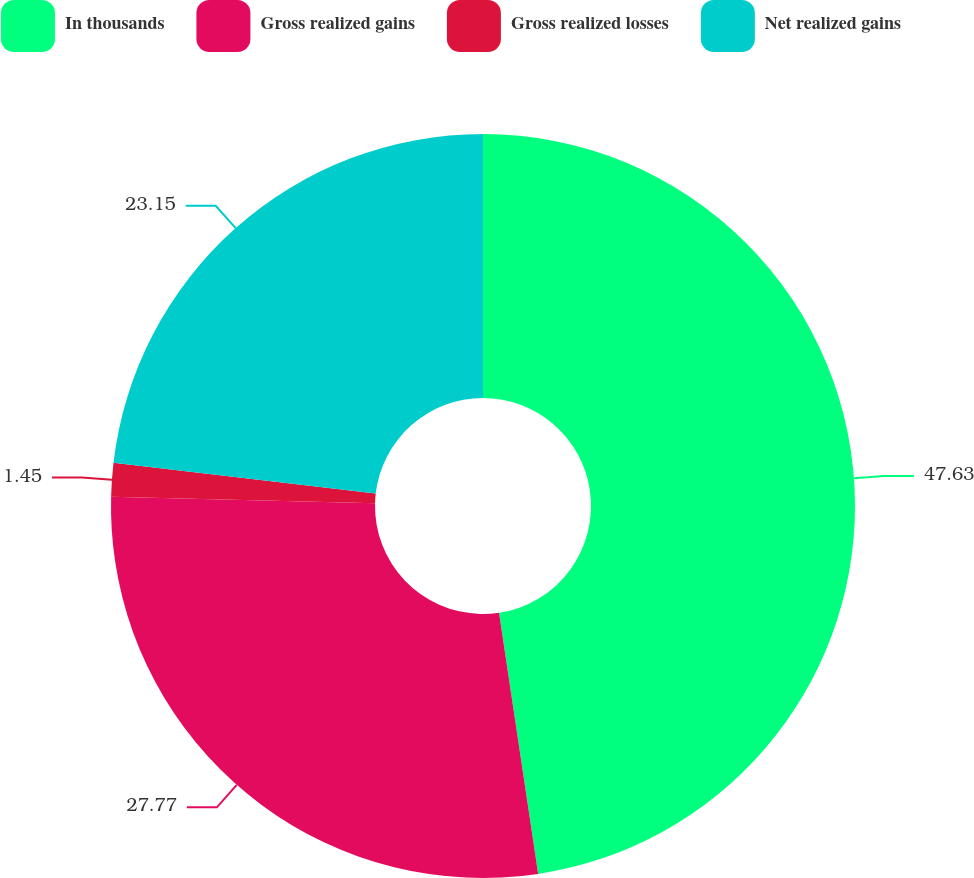<chart> <loc_0><loc_0><loc_500><loc_500><pie_chart><fcel>In thousands<fcel>Gross realized gains<fcel>Gross realized losses<fcel>Net realized gains<nl><fcel>47.63%<fcel>27.77%<fcel>1.45%<fcel>23.15%<nl></chart> 